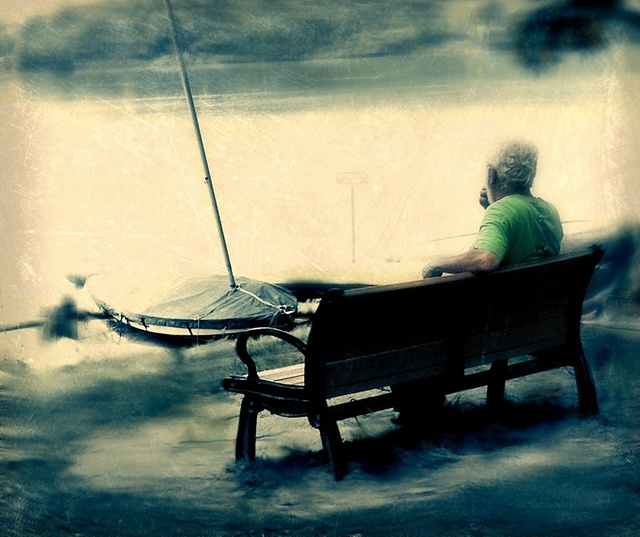Describe the objects in this image and their specific colors. I can see bench in tan, black, teal, and darkgray tones, boat in tan, khaki, black, darkgray, and teal tones, and people in tan, black, gray, teal, and khaki tones in this image. 